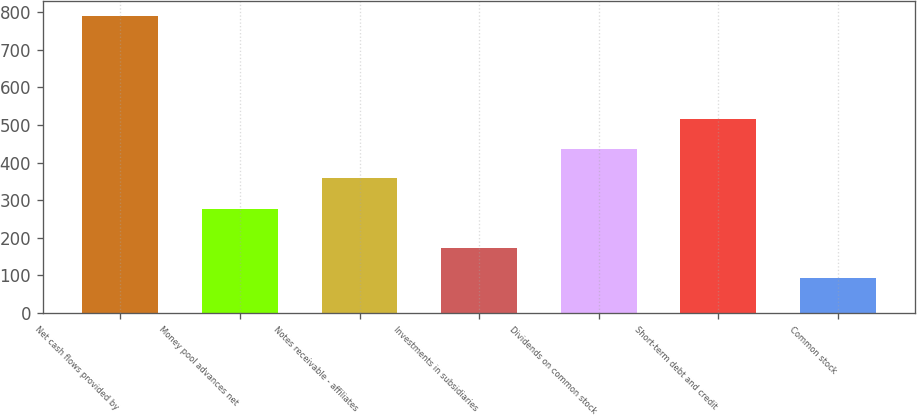<chart> <loc_0><loc_0><loc_500><loc_500><bar_chart><fcel>Net cash flows provided by<fcel>Money pool advances net<fcel>Notes receivable - affiliates<fcel>Investments in subsidiaries<fcel>Dividends on common stock<fcel>Short-term debt and credit<fcel>Common stock<nl><fcel>791<fcel>276<fcel>358<fcel>172<fcel>437<fcel>516<fcel>93<nl></chart> 